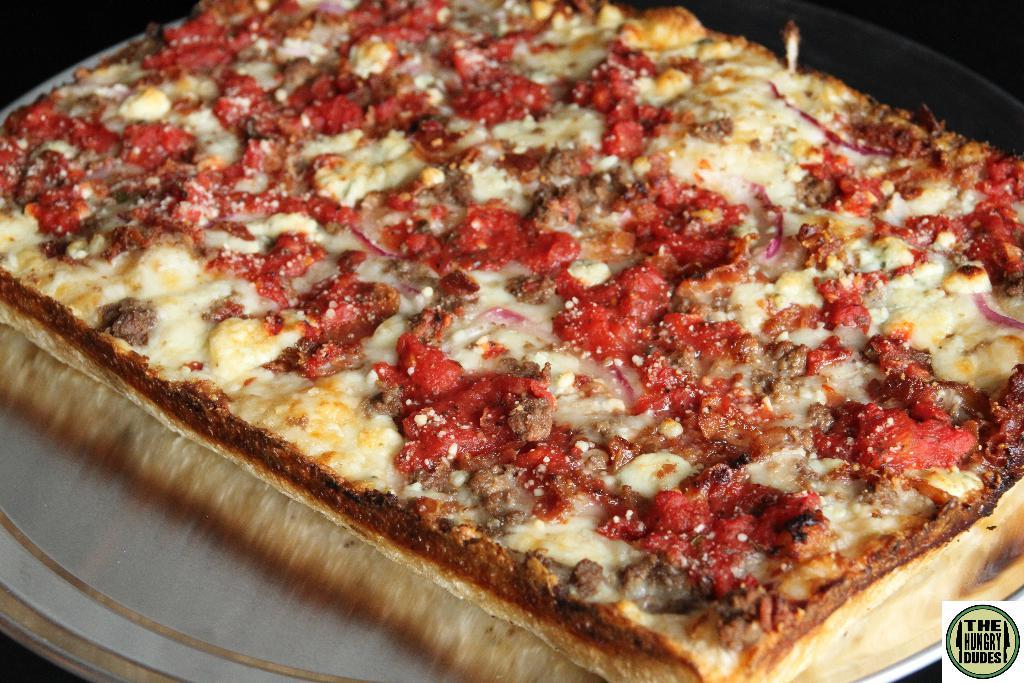What type of food is on the plate in the image? There is a pizza on a plate in the image. What can be seen in the background of the image? The background of the image is dark. How many clovers are visible on the pizza in the image? There are no clovers present on the pizza in the image. Is the person in the image sleeping or awake? There is no person present in the image, so it cannot be determined if someone is sleeping or awake. 